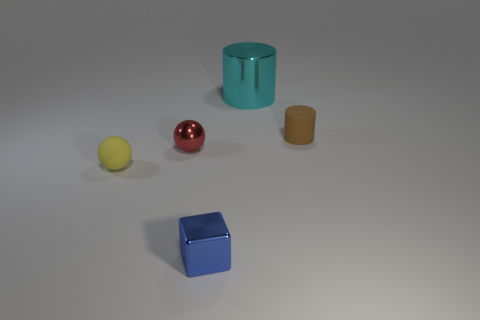What colors are present among the objects, and how do the colors impact the visual aesthetics of the scene? The objects display a palette of colors including teal, red, yellow, beige, and blue. These colors create a harmonious and somewhat muted contrast against the neutral background. The variety of colors and their saturation provide a pleasing visual balance, and the matte surfaces soften the overall aesthetic. 